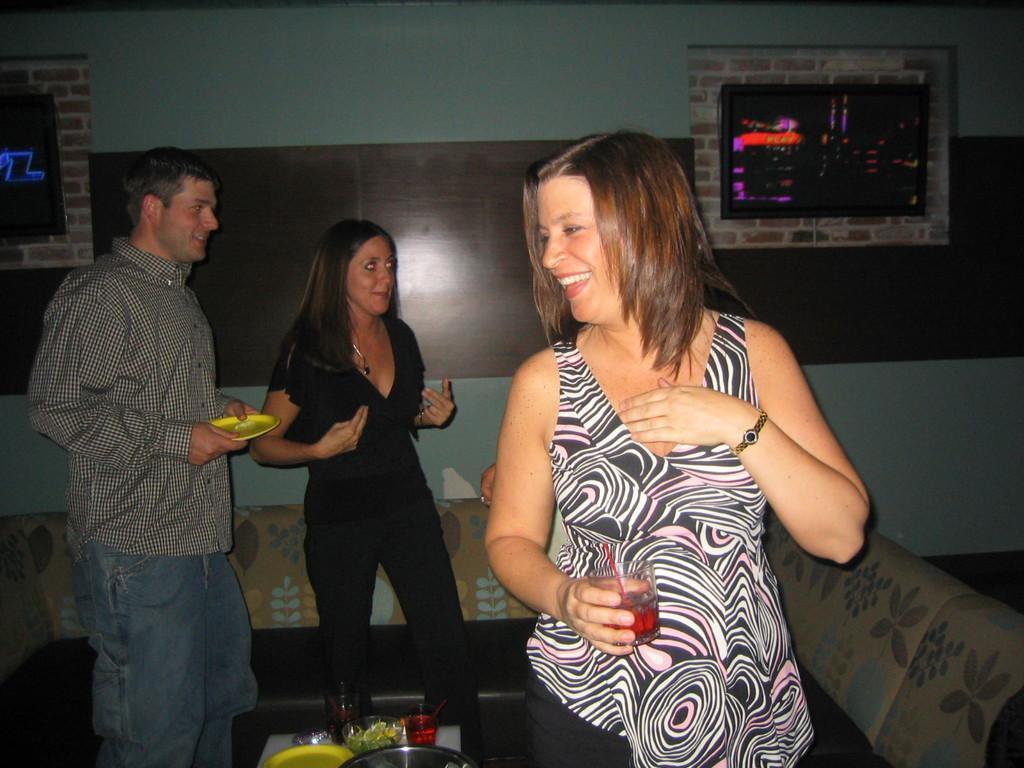Describe this image in one or two sentences. In this image we can see three persons and among them two persons are holding objects. Behind the persons we can see a wall and the couch. On the wall we can see few objects. At the bottom we can see few objects. 